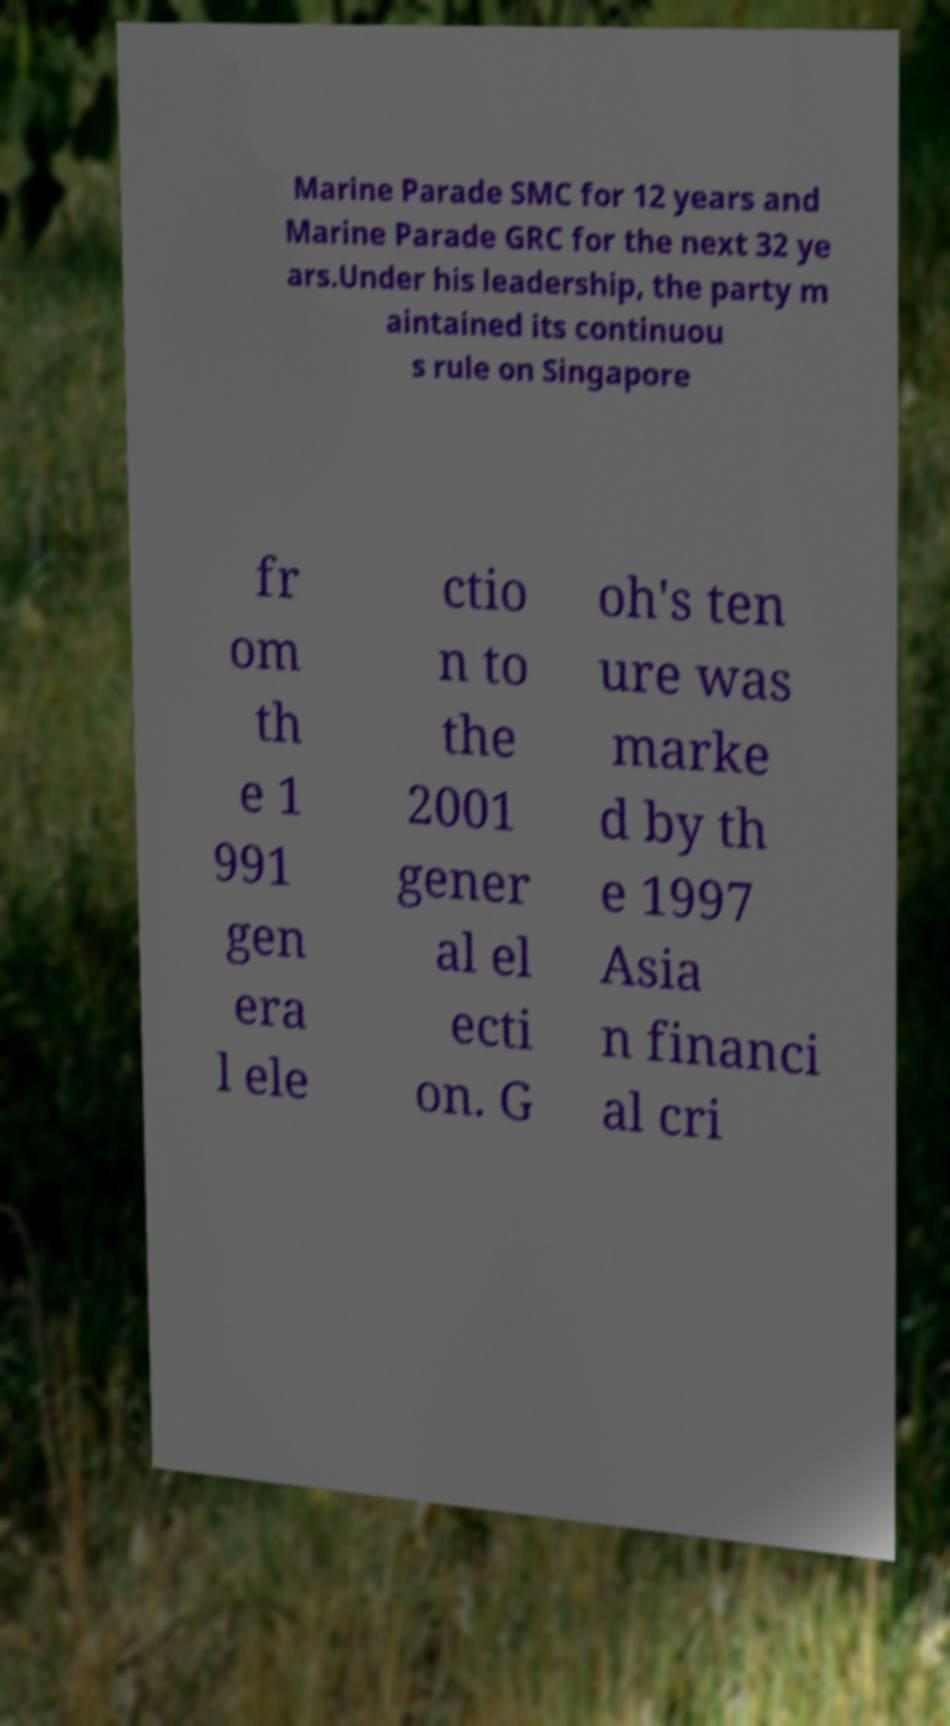Please identify and transcribe the text found in this image. Marine Parade SMC for 12 years and Marine Parade GRC for the next 32 ye ars.Under his leadership, the party m aintained its continuou s rule on Singapore fr om th e 1 991 gen era l ele ctio n to the 2001 gener al el ecti on. G oh's ten ure was marke d by th e 1997 Asia n financi al cri 